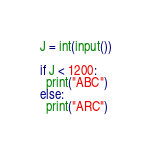Convert code to text. <code><loc_0><loc_0><loc_500><loc_500><_Python_>J = int(input())

if J < 1200:
  print("ABC")
else:
  print("ARC")</code> 